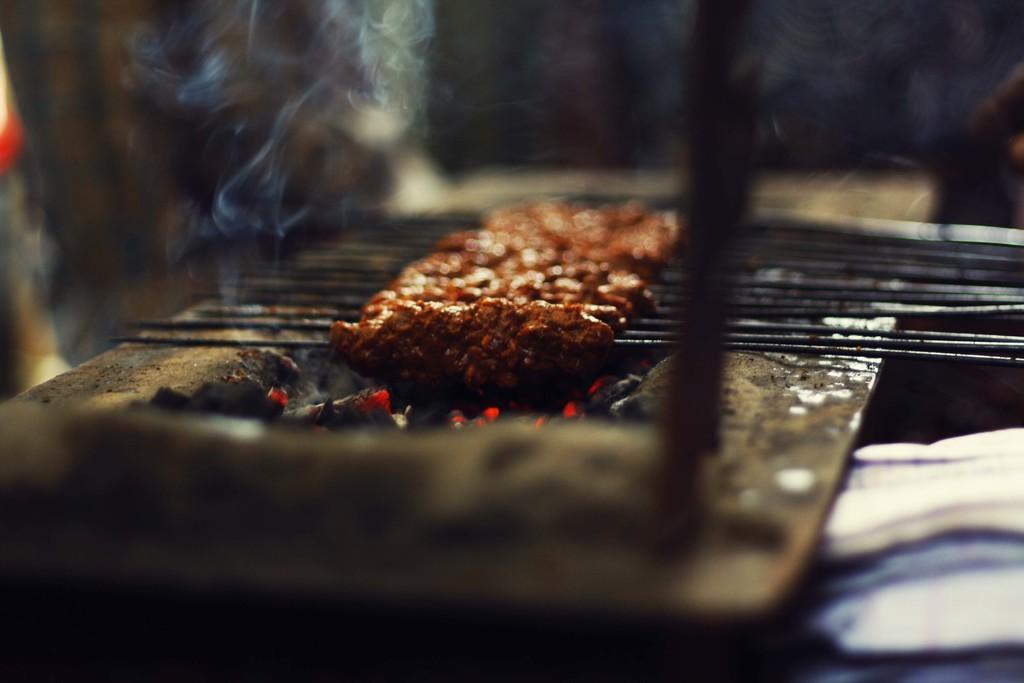Please provide a concise description of this image. In this image we can see barbecue style of cooking on the burning coal which are in a platform. We can see smoke. In the background the image is not clear to describe. 